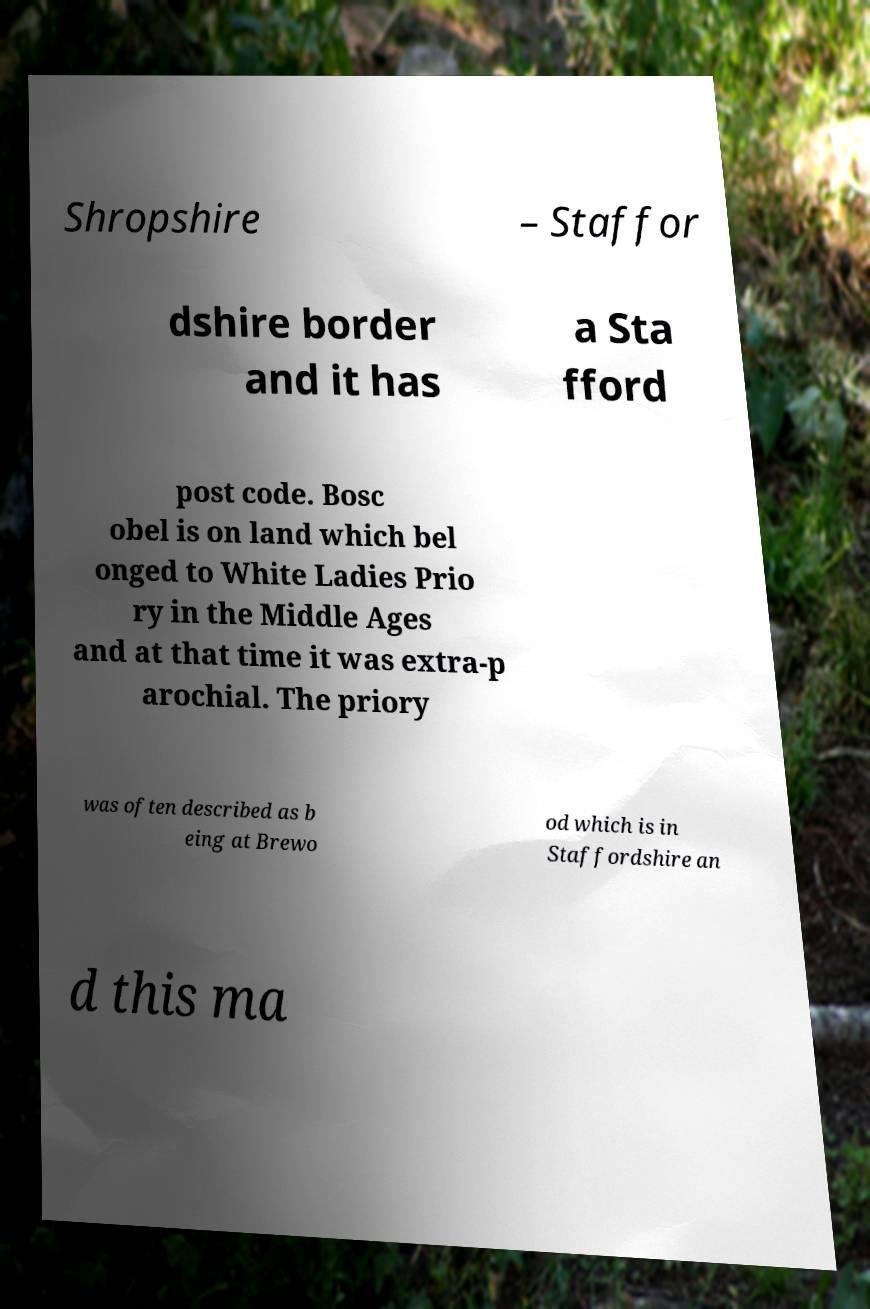Please identify and transcribe the text found in this image. Shropshire – Staffor dshire border and it has a Sta fford post code. Bosc obel is on land which bel onged to White Ladies Prio ry in the Middle Ages and at that time it was extra-p arochial. The priory was often described as b eing at Brewo od which is in Staffordshire an d this ma 